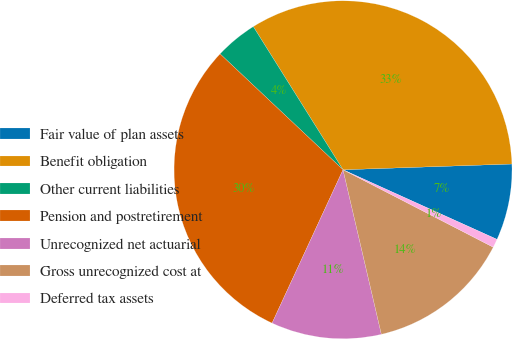<chart> <loc_0><loc_0><loc_500><loc_500><pie_chart><fcel>Fair value of plan assets<fcel>Benefit obligation<fcel>Other current liabilities<fcel>Pension and postretirement<fcel>Unrecognized net actuarial<fcel>Gross unrecognized cost at<fcel>Deferred tax assets<nl><fcel>7.3%<fcel>33.37%<fcel>4.06%<fcel>30.13%<fcel>10.54%<fcel>13.78%<fcel>0.82%<nl></chart> 